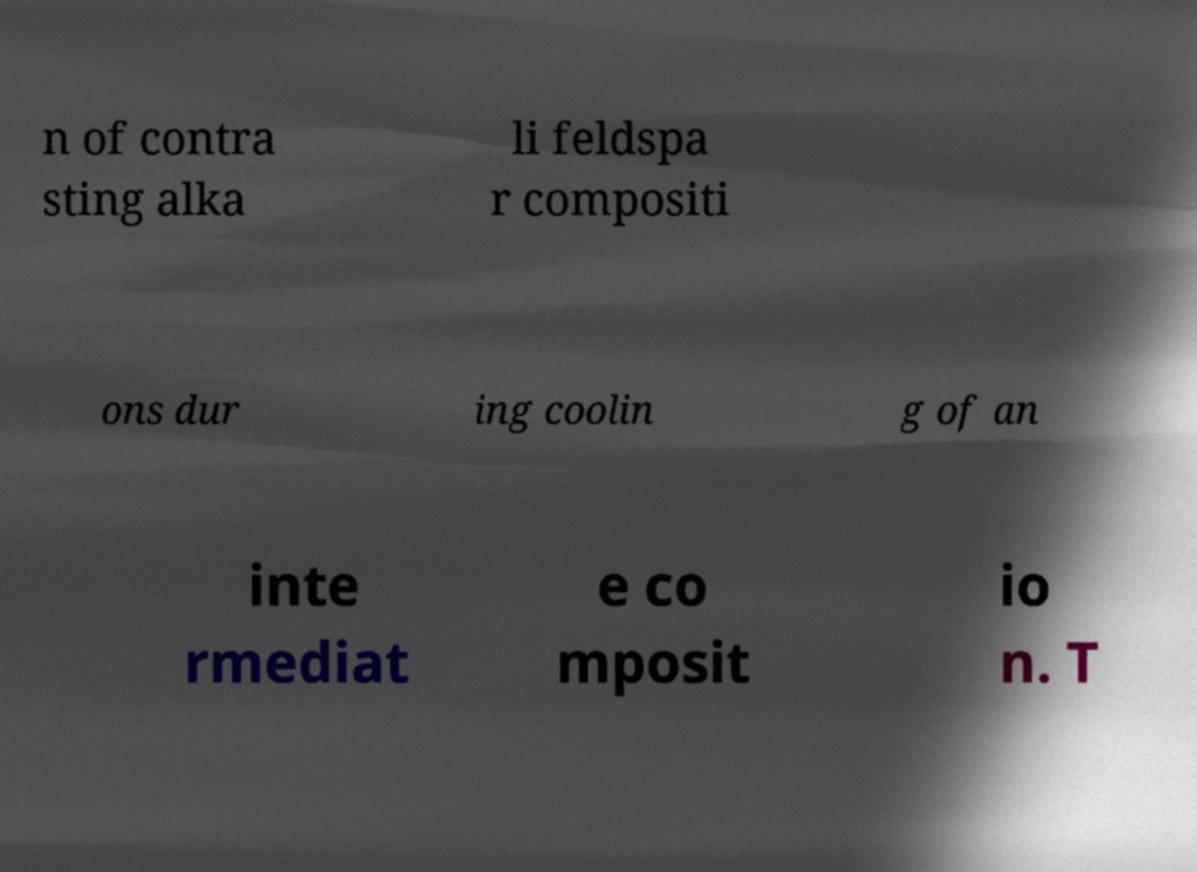Can you read and provide the text displayed in the image?This photo seems to have some interesting text. Can you extract and type it out for me? n of contra sting alka li feldspa r compositi ons dur ing coolin g of an inte rmediat e co mposit io n. T 